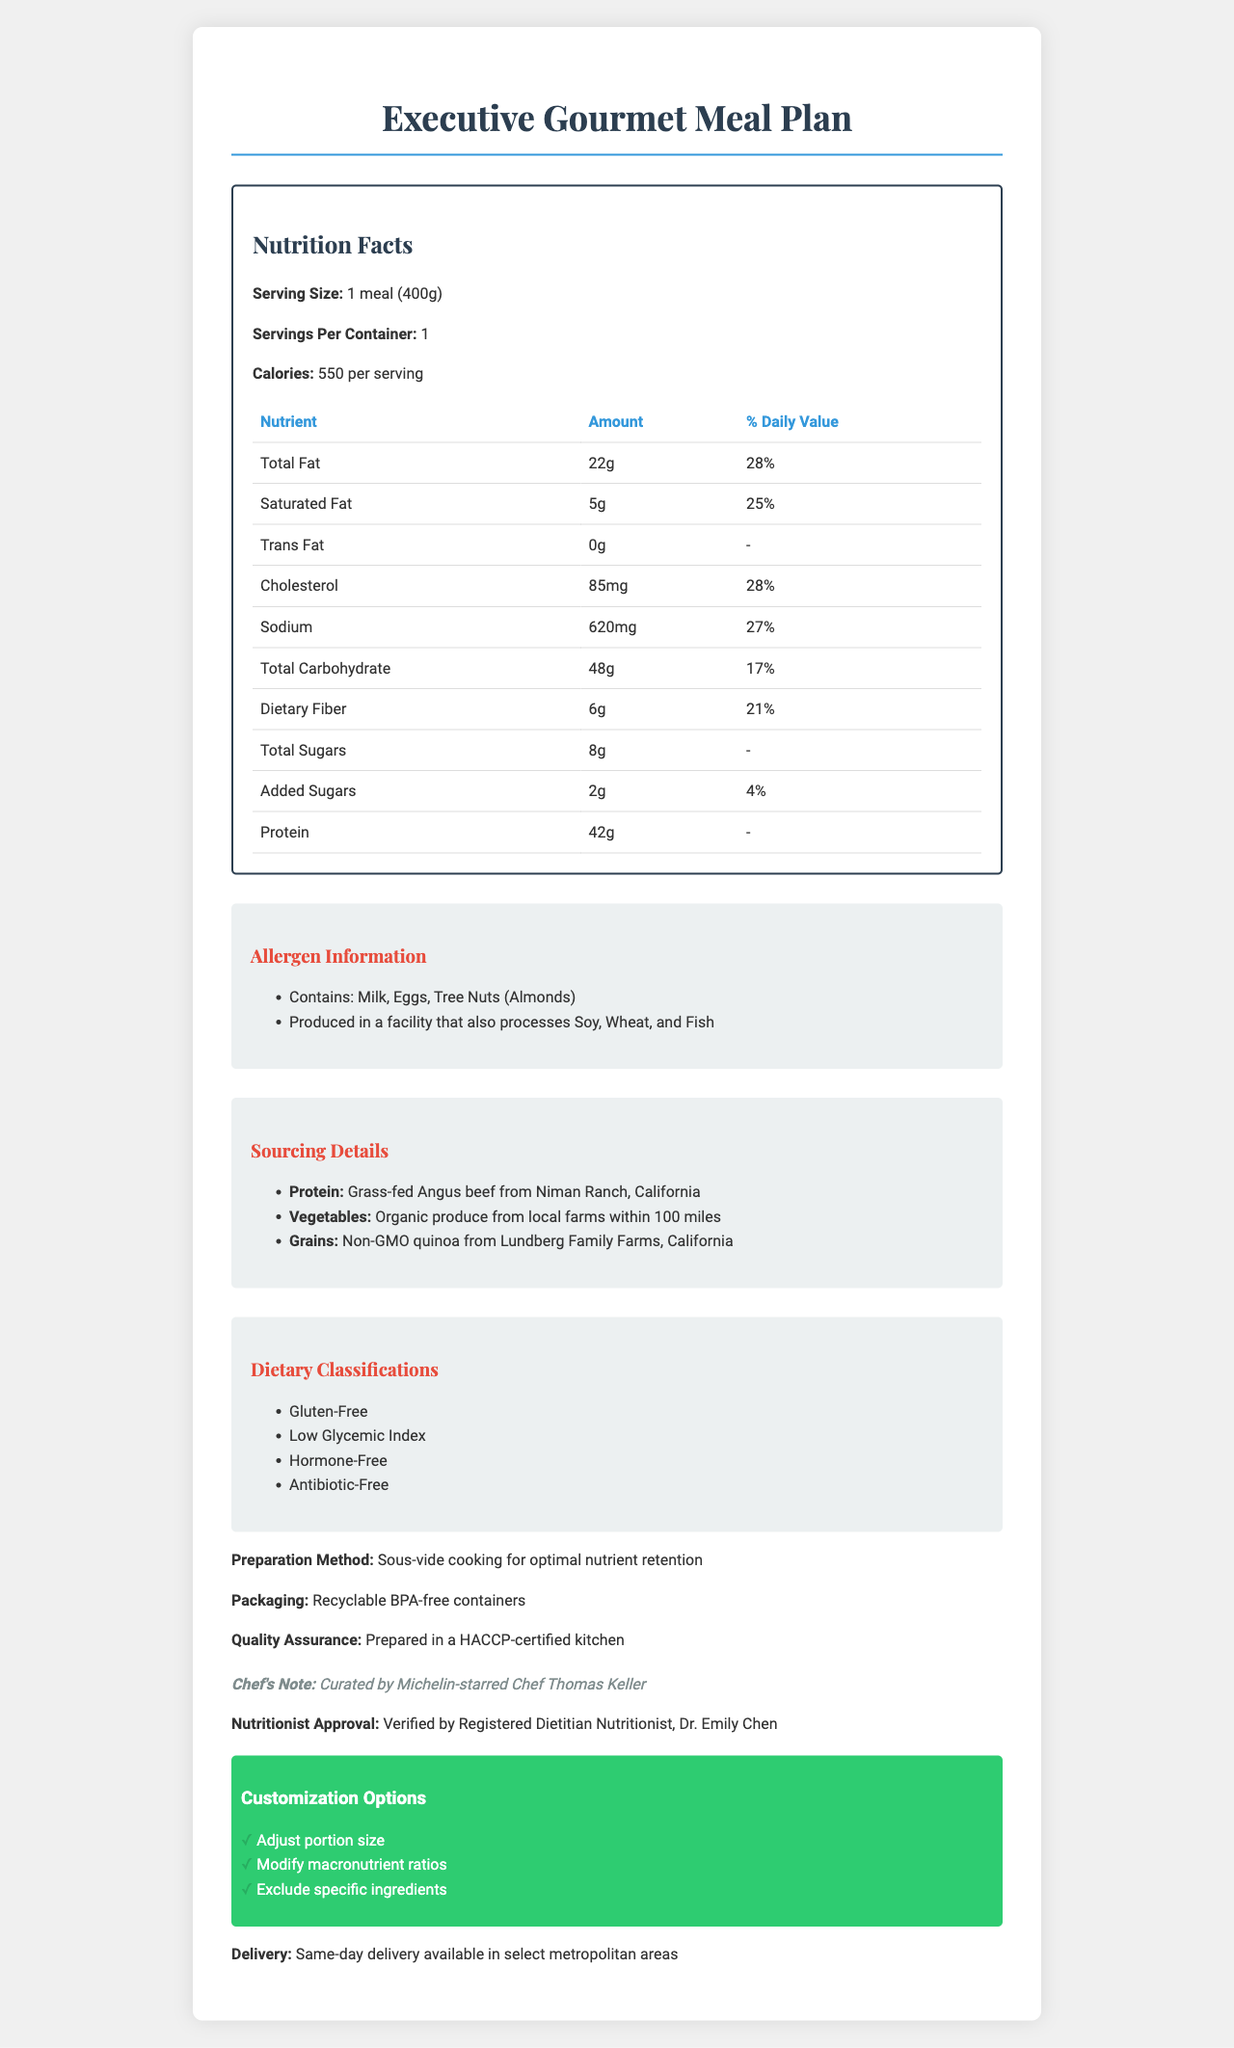what is the product name? The product name is clearly indicated at the top of the document.
Answer: Executive Gourmet Meal Plan What is the serving size for the meal plan? The serving size is listed as "1 meal (400g)" under the Nutrition Facts section.
Answer: 1 meal (400g) How many servings are there per container? The document specifies "Servings Per Container: 1" under the Nutrition Facts section.
Answer: 1 What is the amount of protein in one serving? The amount of protein is listed under the Nutrition Facts table in the macronutrients section as "Protein: 42g".
Answer: 42g What sources are used for the protein in the meal? The sourcing details section specifies that the protein comes from "Grass-fed Angus beef from Niman Ranch, California".
Answer: Grass-fed Angus beef from Niman Ranch, California What are the dietary classifications of the meal plan? A. Vegan B. Gluten-Free C. Contains Soy D. Low in Protein The dietary classifications listed are "Gluten-Free," "Low Glycemic Index," "Hormone-Free," and "Antibiotic-Free." The correct option is B.
Answer: B Which chef curated the meal plan? A. Gordon Ramsay B. Thomas Keller C. Wolfgang Puck The chef's note mentions that the meal is curated by "Michelin-starred Chef Thomas Keller," making B the correct answer.
Answer: B Is the meal suitable for people with a soy allergy? The allergen information indicates that the meal is produced in a facility that also processes soy, hence it is not suitable for people with a soy allergy.
Answer: No Summarize the key elements of the document. The summary includes the main components and features described in the document, providing a comprehensive overview.
Answer: The document details the nutrition facts, allergen information, sourcing details, dietary classifications, preparation method, packaging info, quality assurance, chef's note, nutritionist approval, customization options, and delivery info for the "Executive Gourmet Meal Plan." What is the daily value percentage of calcium in the meal? Under the micronutrients section in the Nutrition Facts, the amount of calcium shows a daily value of 10%.
Answer: 10% How many customization options are available for the meal plan? The customization section lists three options: "Adjust portion size", "Modify macronutrient ratios", and "Exclude specific ingredients".
Answer: Three Which farm provides the non-GMO quinoa for the meal plan? The sourcing details specify that the grains come from "Non-GMO quinoa from Lundberg Family Farms, California".
Answer: Lundberg Family Farms, California Can the meal be delivered on the same day in select metropolitan areas? The delivery info states "Same-day delivery available in select metropolitan areas".
Answer: Yes What preparation method is used for the meal? The preparation method specified in the document is "Sous-vide cooking for optimal nutrient retention".
Answer: Sous-vide cooking What is the amount of potassium in the meal? The amount of potassium is listed under the micronutrients section as "Potassium: 720mg".
Answer: 720mg Which nutrient has the highest daily value percentage in the meal? Both Total Fat and Cholesterol have the highest daily value percentage at 28%, as indicated in the macronutrients section of the Nutrition Facts.
Answer: Total Fat (28%) and Cholesterol (28%) Which allergens are specifically mentioned in the allergen information? The allergen information section lists "Contains: Milk, Eggs, Tree Nuts (Almonds)" as specified allergens.
Answer: Milk, Eggs, Tree Nuts (Almonds) How much sugar is added to the meal? The Nutrition Facts section states that the meal contains "Added Sugars: 2g".
Answer: 2g Who verified the meal's nutrition information? The document mentions that the nutrition information is "Verified by Registered Dietitian Nutritionist, Dr. Emily Chen".
Answer: Dr. Emily Chen, Registered Dietitian Nutritionist Where is the organic produce in the meal sourced from? The sourcing details specify that the vegetables are "Organic produce from local farms within 100 miles".
Answer: Local farms within 100 miles What is the carbohydrate content per serving? The Nutrition Facts section states that the total carbohydrate content per serving is 48g.
Answer: 48g What is the significance of being prepared in a HACCP-certified kitchen? The document mentions "Prepared in a HACCP-certified kitchen" but does not elaborate on the significance or benefits of this certification.
Answer: Not enough information 